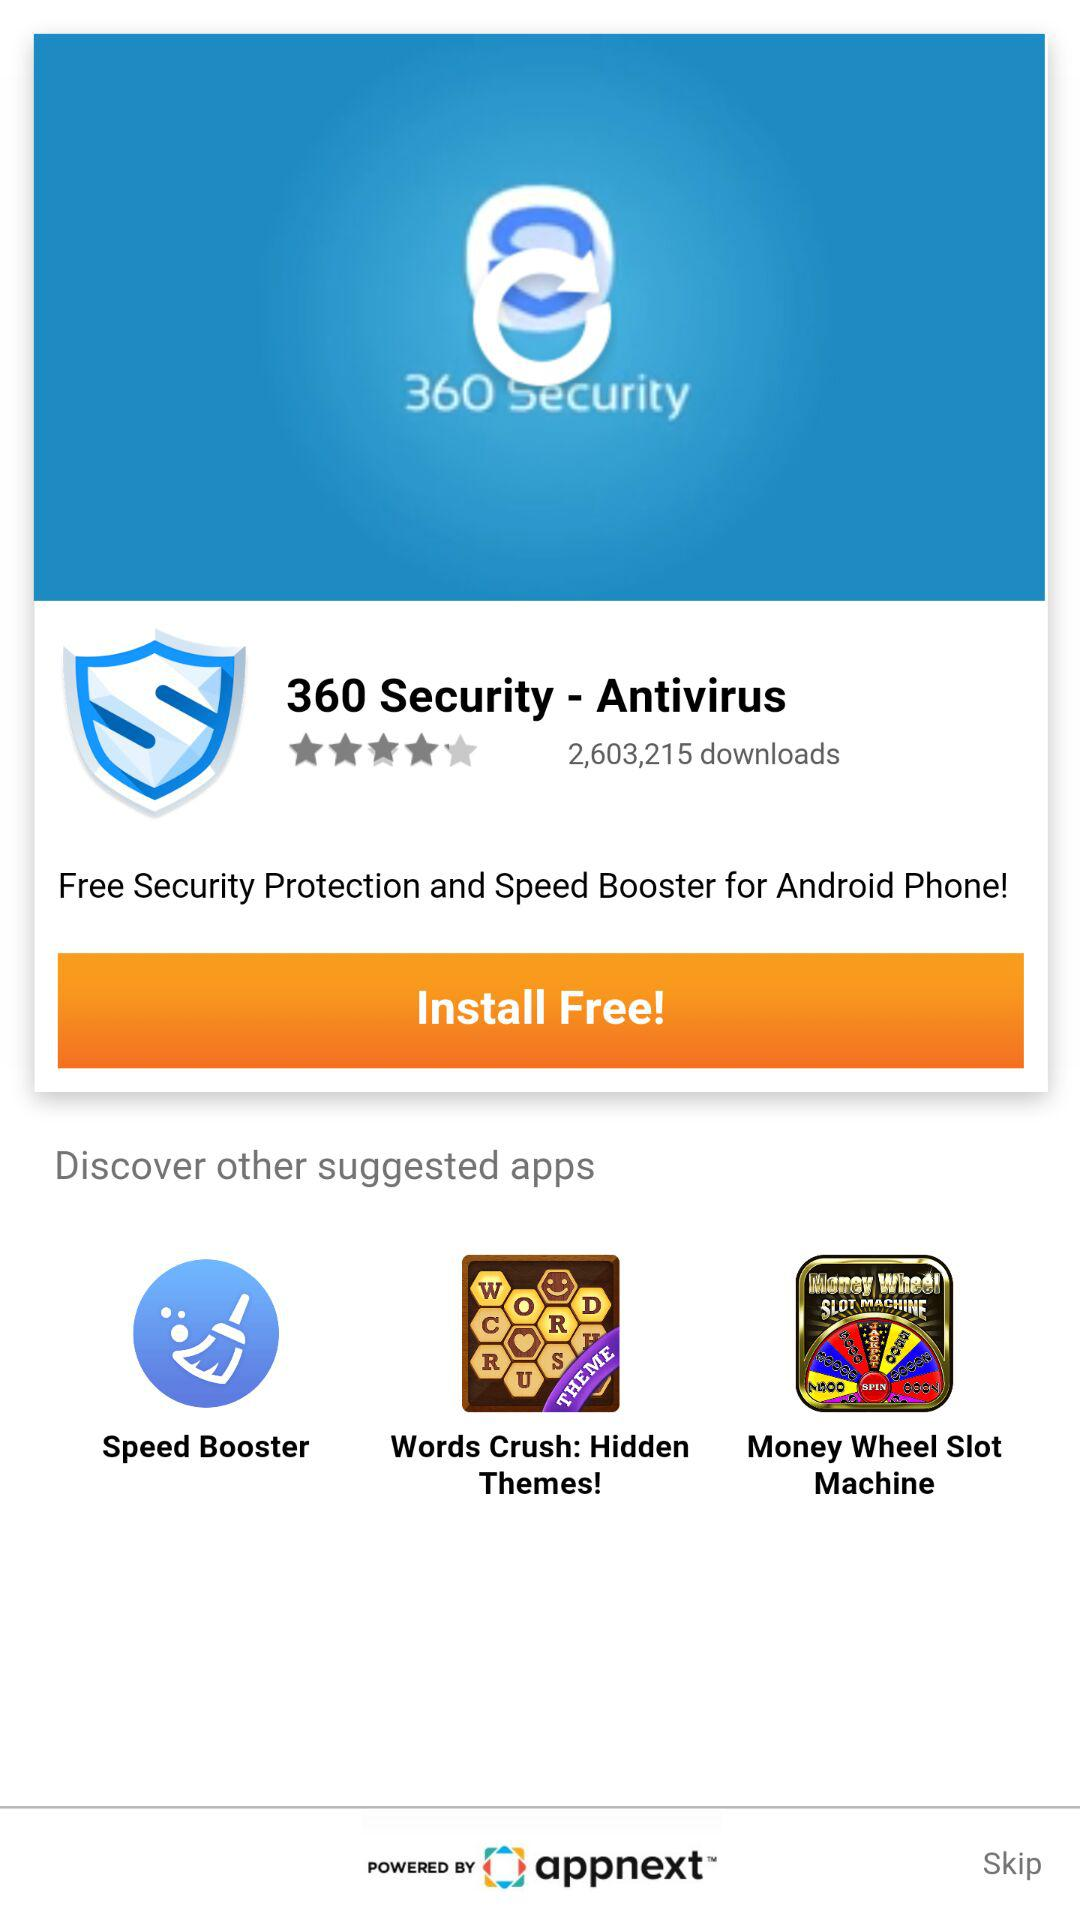What is the rating of the application? The rating is 4 stars. 